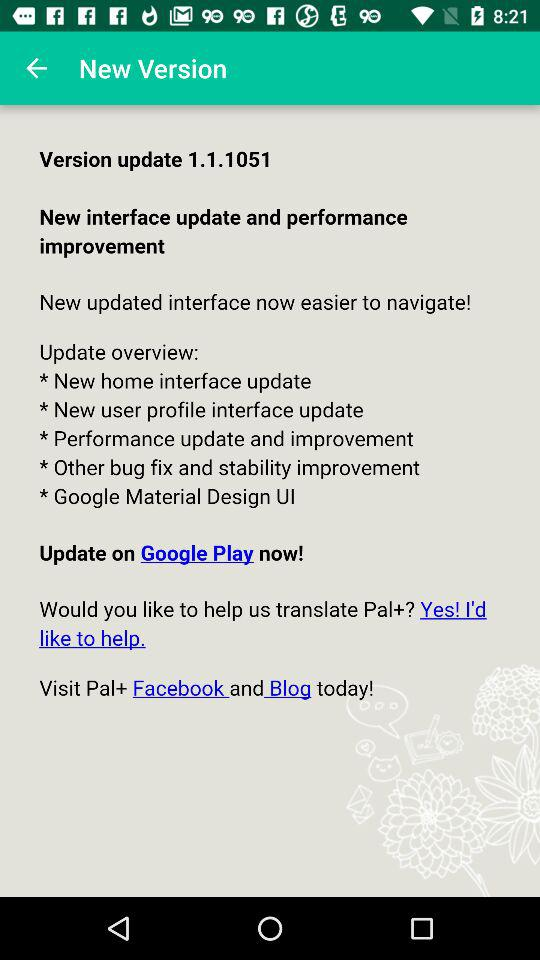What is the new version? The new version is 1.1.1051. 